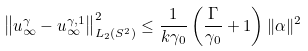<formula> <loc_0><loc_0><loc_500><loc_500>\left \| u ^ { \gamma } _ { \infty } - u ^ { \gamma , 1 } _ { \infty } \right \| ^ { 2 } _ { L _ { 2 } ( S ^ { 2 } ) } \leq \frac { 1 } { k \gamma _ { 0 } } \left ( \frac { \Gamma } { \gamma _ { 0 } } + 1 \right ) \| \alpha \| ^ { 2 }</formula> 